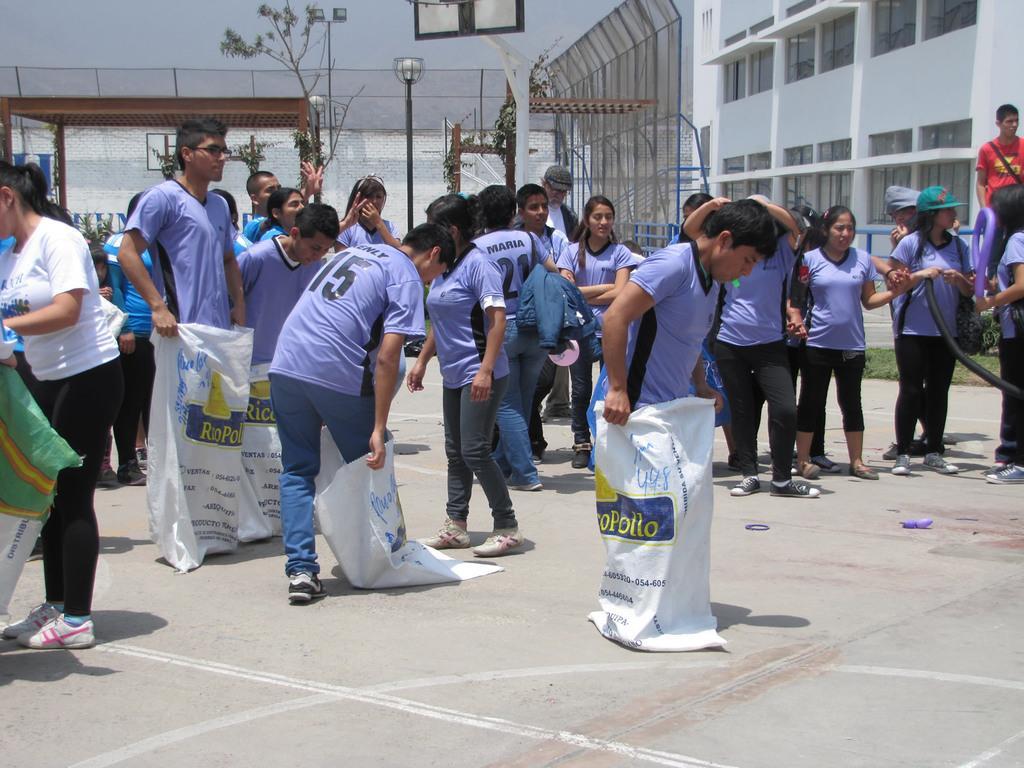Please provide a concise description of this image. There are persons in gray color t-shirts, some of them, wearing covers. On the right side, there is a woman in white color t-shirt, holding a cover. In the background, there are persons in violet color t-shirts, standing on the ground, there is a net, lights attached to the poles, there is a white color building and there is a pole. 